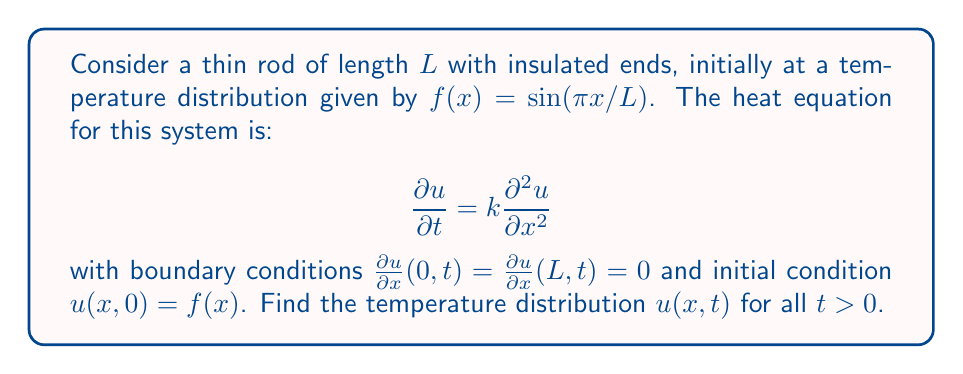Provide a solution to this math problem. 1) For insulated ends, we use the method of separation of variables: $u(x,t) = X(x)T(t)$

2) Substituting into the heat equation:
   $$\frac{T'(t)}{kT(t)} = \frac{X''(x)}{X(x)} = -\lambda$$

3) This gives two ODEs:
   $$T'(t) + k\lambda T(t) = 0$$
   $$X''(x) + \lambda X(x) = 0$$

4) The boundary conditions become:
   $$X'(0) = X'(L) = 0$$

5) Solving the spatial ODE with these conditions gives:
   $$X_n(x) = \cos(\frac{n\pi x}{L}), \quad \lambda_n = (\frac{n\pi}{L})^2, \quad n = 0,1,2,...$$

6) The temporal ODE solution is:
   $$T_n(t) = e^{-k(\frac{n\pi}{L})^2t}$$

7) The general solution is:
   $$u(x,t) = \sum_{n=0}^{\infty} A_n \cos(\frac{n\pi x}{L}) e^{-k(\frac{n\pi}{L})^2t}$$

8) Using the initial condition:
   $$f(x) = \sin(\frac{\pi x}{L}) = \sum_{n=0}^{\infty} A_n \cos(\frac{n\pi x}{L})$$

9) This implies $A_1 = 1$ and all other $A_n = 0$

10) Therefore, the final solution is:
    $$u(x,t) = \sin(\frac{\pi x}{L}) e^{-k(\frac{\pi}{L})^2t}$$
Answer: $u(x,t) = \sin(\frac{\pi x}{L}) e^{-k(\frac{\pi}{L})^2t}$ 